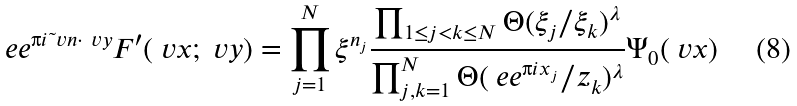<formula> <loc_0><loc_0><loc_500><loc_500>\ e e ^ { \i i \tilde { \ } v n \cdot \ v y } F ^ { \prime } ( \ v x ; \ v y ) = \prod _ { j = 1 } ^ { N } \xi ^ { n _ { j } } \frac { \prod _ { 1 \leq j < k \leq N } \Theta ( \xi _ { j } / \xi _ { k } ) ^ { \lambda } } { \prod _ { j , k = 1 } ^ { N } \Theta ( \ e e ^ { \i i x _ { j } } / z _ { k } ) ^ { \lambda } } \Psi _ { 0 } ( \ v x )</formula> 